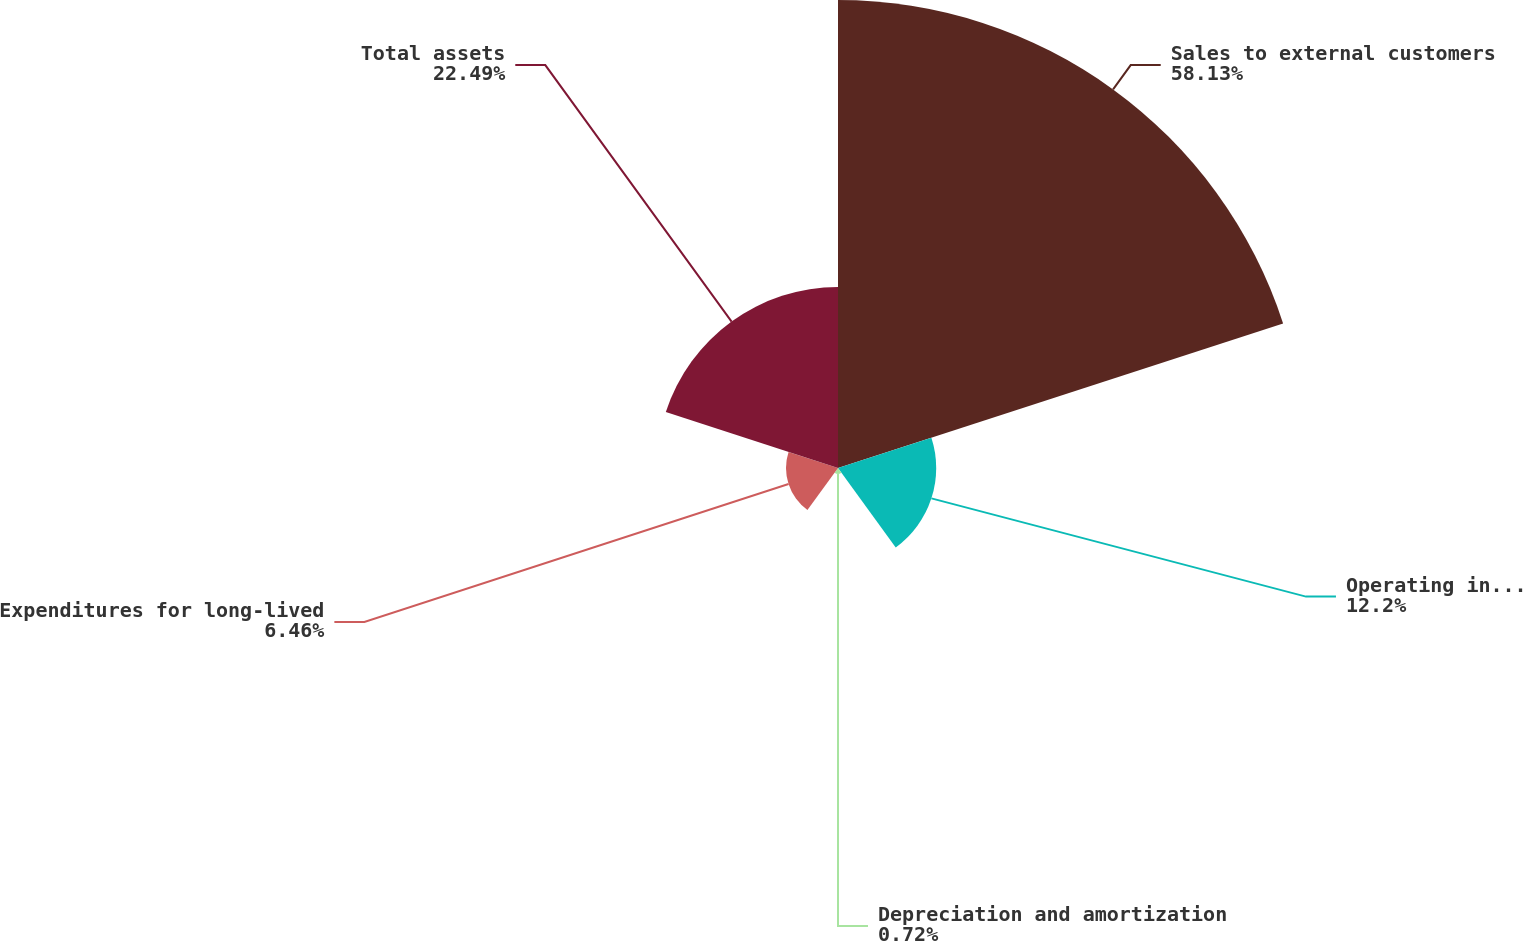<chart> <loc_0><loc_0><loc_500><loc_500><pie_chart><fcel>Sales to external customers<fcel>Operating income (loss)<fcel>Depreciation and amortization<fcel>Expenditures for long-lived<fcel>Total assets<nl><fcel>58.14%<fcel>12.2%<fcel>0.72%<fcel>6.46%<fcel>22.49%<nl></chart> 